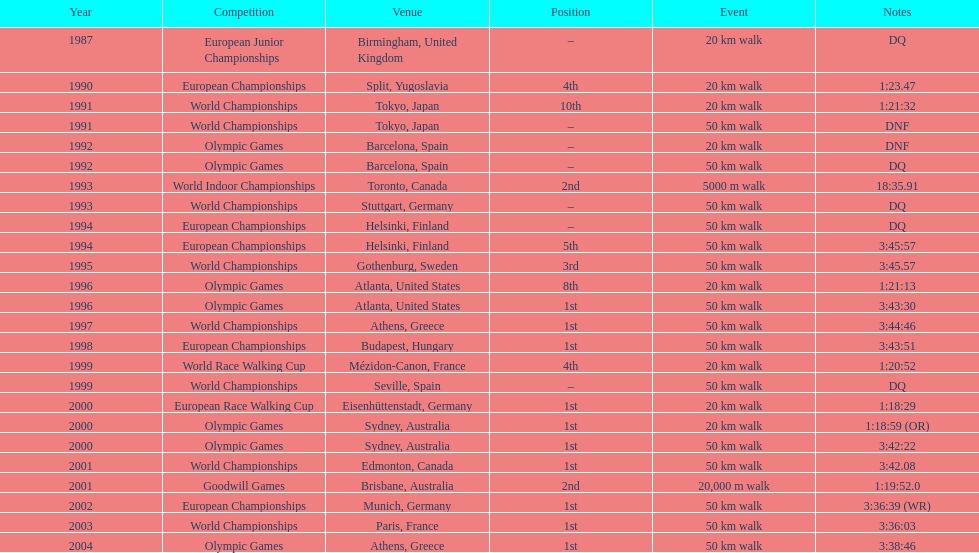In 1990, at what rank did robert korzeniowski end? 4th. In 1993, what was robert korzeniowski's position in the world indoor championships? 2nd. How much time did the 50km walk in the 2004 olympics require? 3:38:46. 